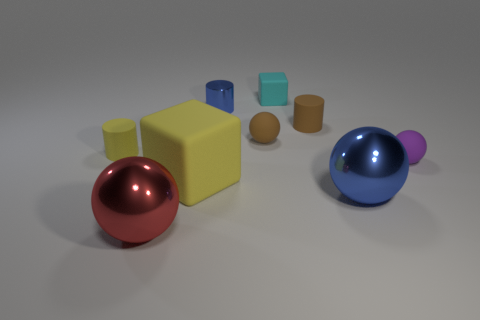What number of blue objects are either metallic cylinders or large spheres?
Ensure brevity in your answer.  2. There is a tiny thing that is behind the metal cylinder; what is its material?
Keep it short and to the point. Rubber. There is a large metal ball that is on the left side of the large matte thing; how many large blue shiny objects are in front of it?
Give a very brief answer. 0. How many yellow matte objects are the same shape as the tiny purple object?
Your answer should be compact. 0. What number of tiny shiny things are there?
Your answer should be very brief. 1. The rubber cube behind the small yellow matte thing is what color?
Keep it short and to the point. Cyan. What color is the tiny matte sphere in front of the small sphere on the left side of the purple matte object?
Your answer should be compact. Purple. The shiny object that is the same size as the cyan rubber object is what color?
Provide a short and direct response. Blue. What number of objects are both in front of the large cube and on the left side of the large blue shiny sphere?
Your answer should be compact. 1. There is another matte object that is the same color as the big matte object; what shape is it?
Make the answer very short. Cylinder. 